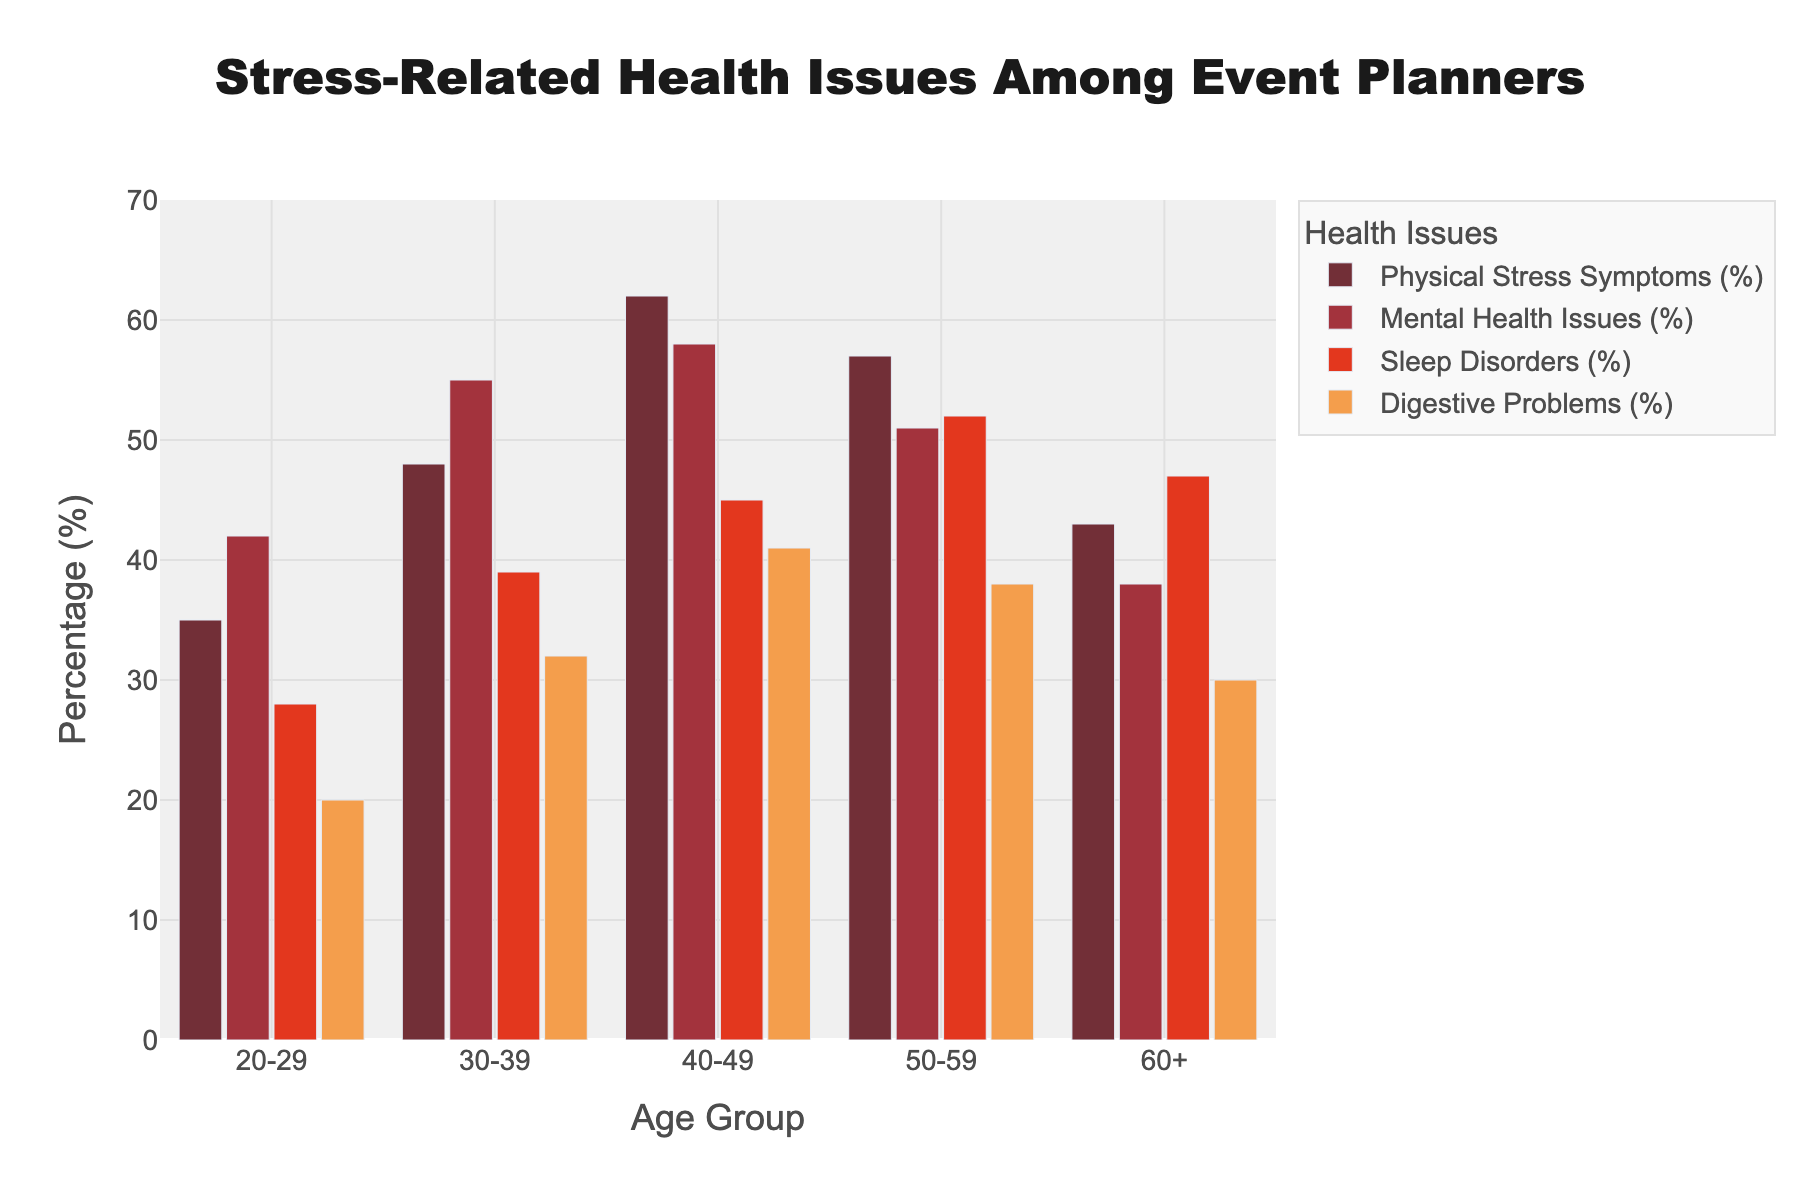What age group has the highest percentage of physical stress symptoms? To find the answer, look at the height of the bars representing physical stress symptoms for each age group. The tallest bar corresponds to the 40-49 age group with a value of 62%.
Answer: 40-49 Which age group experiences the least mental health issues? Examine the height of the bars representing mental health issues for each age group. The group with the shortest bar is the 60+ age group at 38%.
Answer: 60+ In the age group 50-59, how much higher is the percentage of sleep disorders compared to digestive problems? Check the height of the bars for sleep disorders and digestive problems in the 50-59 age group. Sleep disorders are at 52%, and digestive problems are at 38%. The difference is 52% - 38% = 14%.
Answer: 14% Which health issue has the highest percentage among the 30-39 age group? Compare the heights of the bars for different health issues within the 30-39 age group. The bar for mental health issues is the highest at 55%.
Answer: Mental Health Issues Between age groups 20-29 and 30-39, which group has a higher average percentage of all health issues combined? Calculate the average for each group: For 20-29, the average is (35% + 42% + 28% + 20%) / 4 = 31.25%. For 30-39, the average is (48% + 55% + 39% + 32%) / 4 = 43.5%. The 30-39 age group has a higher average.
Answer: 30-39 How does the percentage of digestive problems in the 40-49 age group compare to that in the 20-29 age group? Compare the heights of the digestive problems bars. The 40-49 age group has 41%, whereas the 20-29 age group has 20%. The 40-49 age group has a higher percentage by 21%.
Answer: 21% higher Which age group has the most varied health issue percentages, and what is the range? For each age group, calculate the range by subtracting the smallest percentage from the largest. The ranges are: 20-29: 42% - 20% = 22%, 30-39: 55% - 32% = 23%, 40-49: 62% - 41% = 21%, 50-59: 57% - 38% = 19%, 60+: 47% - 30% = 17%. The 30-39 age group has the most varied health issue percentages with a range of 23%.
Answer: 30-39, 23% What is the total percentage of all types of stress-related health issues in the 40-49 age group? Add up the percentages of all health issues for the 40-49 age group: 62% + 58% + 45% + 41% = 206%.
Answer: 206% In the 60+ group, which health issue has experienced a decrease compared to the 50-59 age group? Compare the bars for each health issue between the groups. Physical stress symptoms decreased from 57% to 43%, mental health issues from 51% to 38%, and digestive problems from 38% to 30%. The sleep disorders bar increased from 52% to 47%.
Answer: Physical stress symptoms, mental health issues, digestive problems 